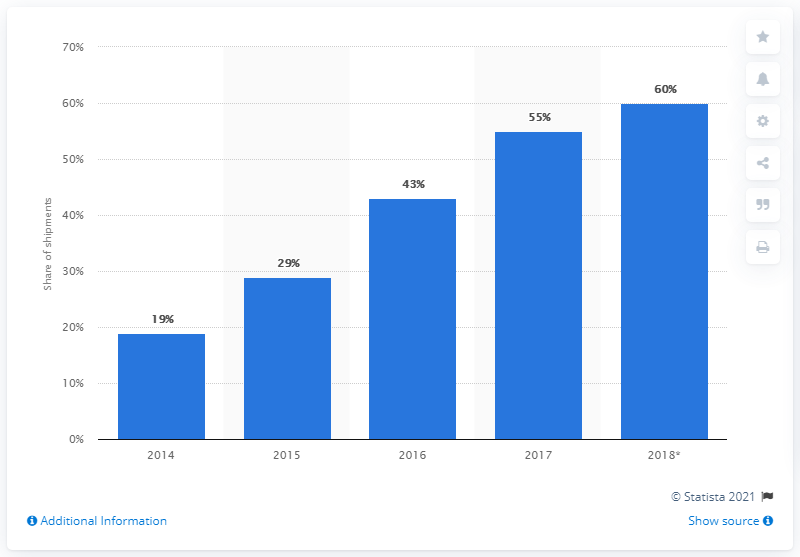Mention a couple of crucial points in this snapshot. The year 2014 is the first year shown in the chart. Based on the chart provided, the average GPA for first-year students and last-year students is 39.5. 